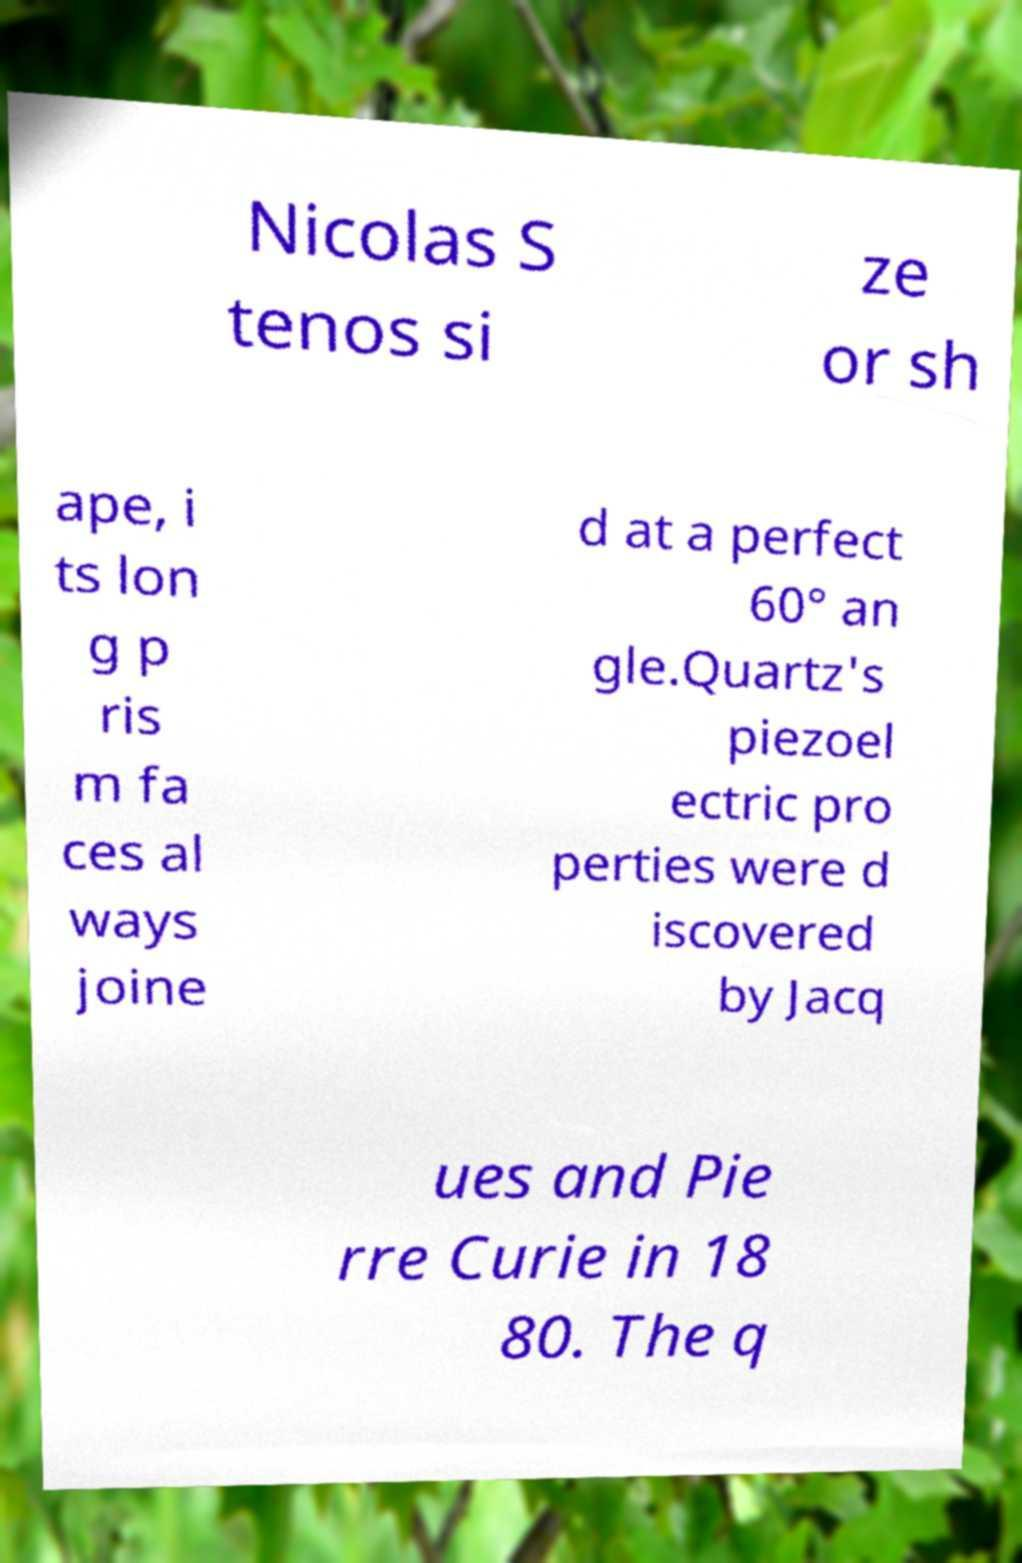For documentation purposes, I need the text within this image transcribed. Could you provide that? Nicolas S tenos si ze or sh ape, i ts lon g p ris m fa ces al ways joine d at a perfect 60° an gle.Quartz's piezoel ectric pro perties were d iscovered by Jacq ues and Pie rre Curie in 18 80. The q 